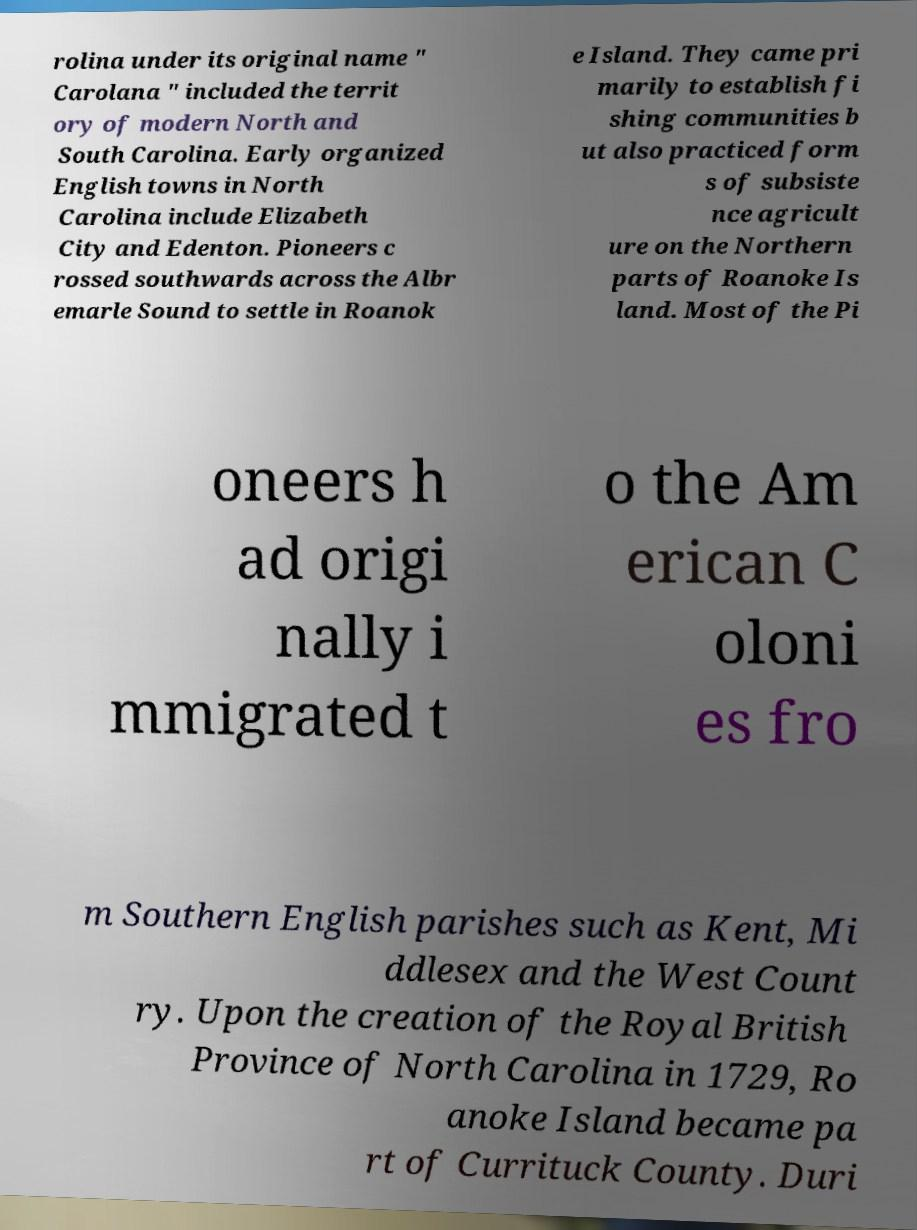Could you extract and type out the text from this image? rolina under its original name " Carolana " included the territ ory of modern North and South Carolina. Early organized English towns in North Carolina include Elizabeth City and Edenton. Pioneers c rossed southwards across the Albr emarle Sound to settle in Roanok e Island. They came pri marily to establish fi shing communities b ut also practiced form s of subsiste nce agricult ure on the Northern parts of Roanoke Is land. Most of the Pi oneers h ad origi nally i mmigrated t o the Am erican C oloni es fro m Southern English parishes such as Kent, Mi ddlesex and the West Count ry. Upon the creation of the Royal British Province of North Carolina in 1729, Ro anoke Island became pa rt of Currituck County. Duri 